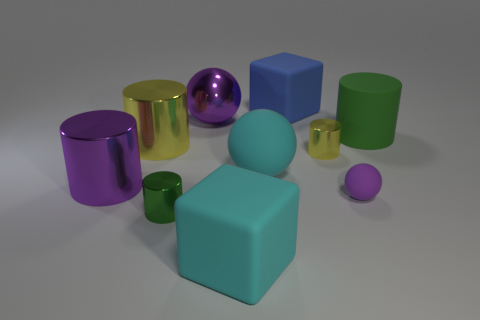Is the color of the block in front of the big yellow cylinder the same as the metallic sphere? no 